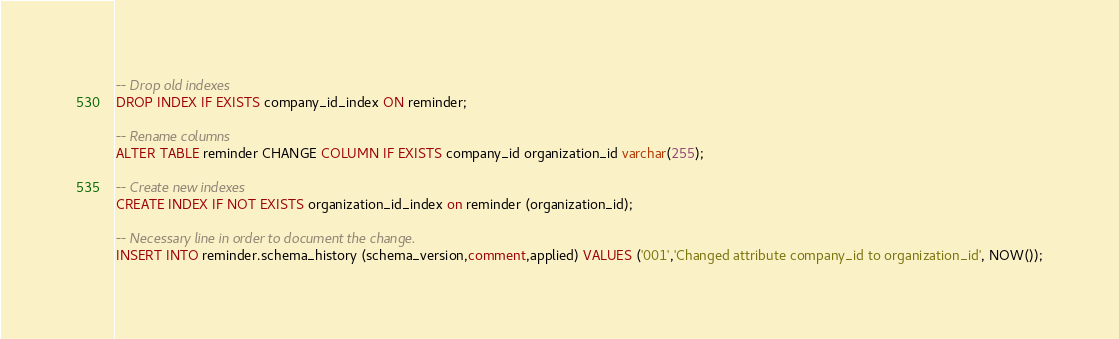Convert code to text. <code><loc_0><loc_0><loc_500><loc_500><_SQL_>-- Drop old indexes
DROP INDEX IF EXISTS company_id_index ON reminder;

-- Rename columns
ALTER TABLE reminder CHANGE COLUMN IF EXISTS company_id organization_id varchar(255);

-- Create new indexes
CREATE INDEX IF NOT EXISTS organization_id_index on reminder (organization_id);

-- Necessary line in order to document the change.
INSERT INTO reminder.schema_history (schema_version,comment,applied) VALUES ('001','Changed attribute company_id to organization_id', NOW());</code> 